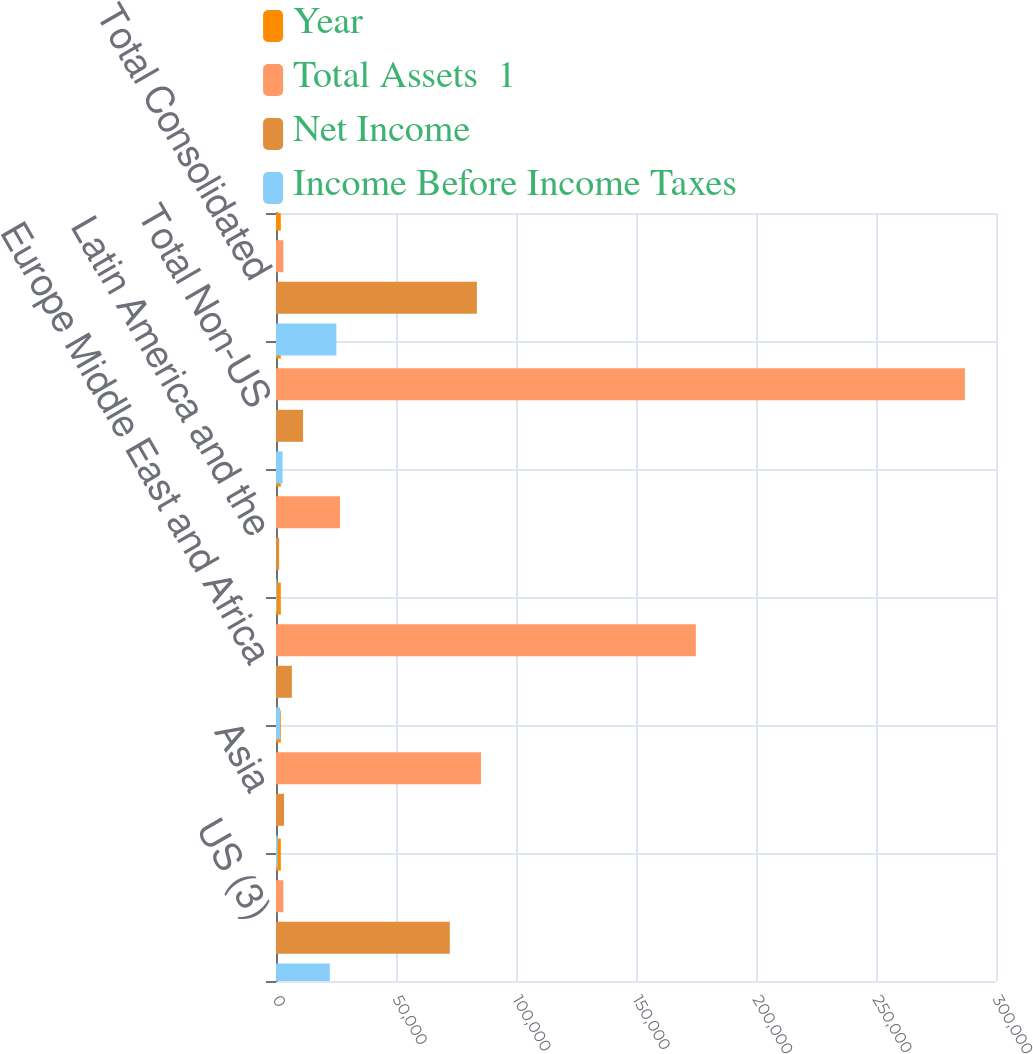Convert chart to OTSL. <chart><loc_0><loc_0><loc_500><loc_500><stacked_bar_chart><ecel><fcel>US (3)<fcel>Asia<fcel>Europe Middle East and Africa<fcel>Latin America and the<fcel>Total Non-US<fcel>Total Consolidated<nl><fcel>Year<fcel>2016<fcel>2016<fcel>2016<fcel>2016<fcel>2016<fcel>2016<nl><fcel>Total Assets  1<fcel>3052<fcel>85410<fcel>174934<fcel>26680<fcel>287024<fcel>3052<nl><fcel>Net Income<fcel>72418<fcel>3365<fcel>6608<fcel>1310<fcel>11283<fcel>83701<nl><fcel>Income Before Income Taxes<fcel>22414<fcel>674<fcel>1705<fcel>360<fcel>2739<fcel>25153<nl></chart> 